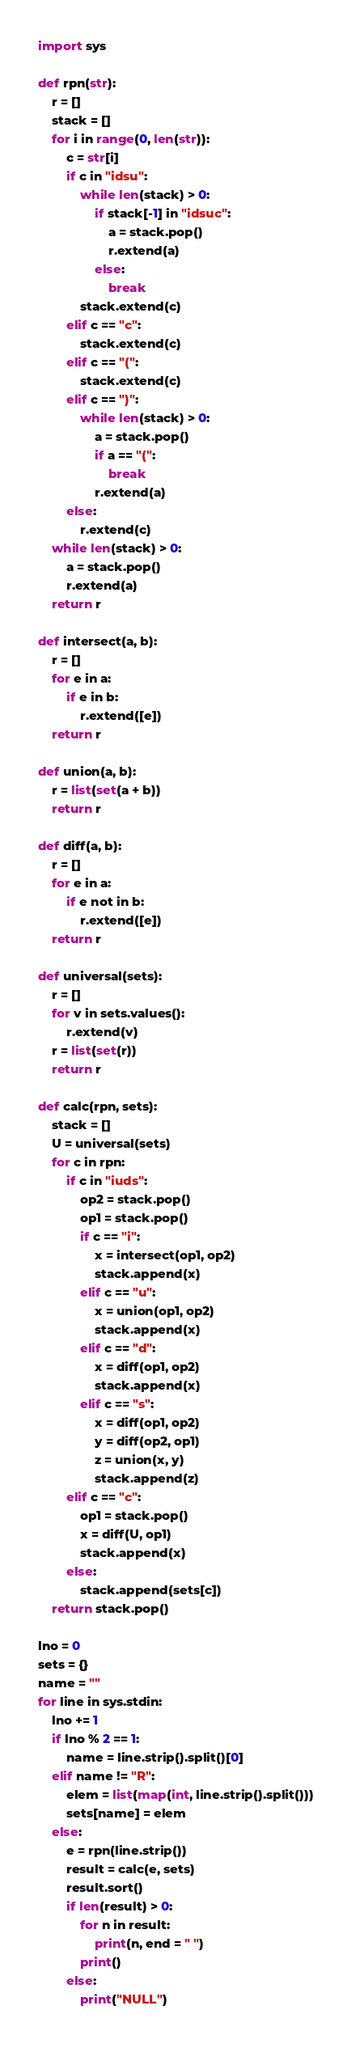<code> <loc_0><loc_0><loc_500><loc_500><_Python_>import sys

def rpn(str):
    r = []
    stack = []
    for i in range(0, len(str)):
        c = str[i]
        if c in "idsu":
            while len(stack) > 0:
                if stack[-1] in "idsuc":
                    a = stack.pop()
                    r.extend(a)
                else:
                    break
            stack.extend(c)
        elif c == "c":
            stack.extend(c)
        elif c == "(":
            stack.extend(c)
        elif c == ")":
            while len(stack) > 0:
                a = stack.pop()
                if a == "(":
                    break
                r.extend(a)
        else:
            r.extend(c)
    while len(stack) > 0:
        a = stack.pop()
        r.extend(a)
    return r

def intersect(a, b):
    r = []
    for e in a:
        if e in b:
            r.extend([e])
    return r

def union(a, b):
    r = list(set(a + b))
    return r

def diff(a, b):
    r = []
    for e in a:
        if e not in b:
            r.extend([e])
    return r

def universal(sets):
    r = []
    for v in sets.values():
        r.extend(v)
    r = list(set(r))
    return r

def calc(rpn, sets):
    stack = []
    U = universal(sets)
    for c in rpn:
        if c in "iuds":
            op2 = stack.pop()
            op1 = stack.pop()
            if c == "i":
                x = intersect(op1, op2)
                stack.append(x)
            elif c == "u":
                x = union(op1, op2)
                stack.append(x)
            elif c == "d":
                x = diff(op1, op2)
                stack.append(x)
            elif c == "s":
                x = diff(op1, op2)
                y = diff(op2, op1)
                z = union(x, y)
                stack.append(z)
        elif c == "c":
            op1 = stack.pop()
            x = diff(U, op1)
            stack.append(x)
        else:
            stack.append(sets[c])
    return stack.pop()
            
lno = 0
sets = {}
name = ""
for line in sys.stdin:
    lno += 1
    if lno % 2 == 1:
        name = line.strip().split()[0]
    elif name != "R":
        elem = list(map(int, line.strip().split()))
        sets[name] = elem
    else:
        e = rpn(line.strip())
        result = calc(e, sets)
        result.sort()
        if len(result) > 0:
            for n in result:
                print(n, end = " ")
            print()
        else:
            print("NULL")
</code> 